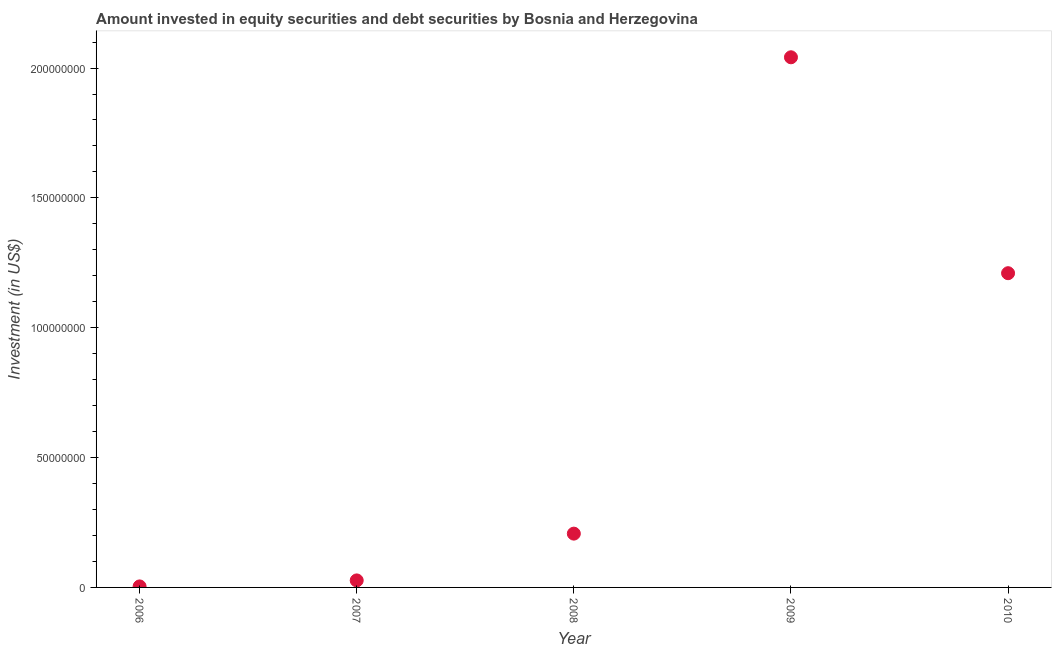What is the portfolio investment in 2006?
Give a very brief answer. 3.88e+05. Across all years, what is the maximum portfolio investment?
Give a very brief answer. 2.04e+08. Across all years, what is the minimum portfolio investment?
Your answer should be very brief. 3.88e+05. What is the sum of the portfolio investment?
Provide a succinct answer. 3.49e+08. What is the difference between the portfolio investment in 2006 and 2007?
Ensure brevity in your answer.  -2.31e+06. What is the average portfolio investment per year?
Your answer should be compact. 6.98e+07. What is the median portfolio investment?
Your answer should be compact. 2.07e+07. In how many years, is the portfolio investment greater than 90000000 US$?
Give a very brief answer. 2. What is the ratio of the portfolio investment in 2006 to that in 2008?
Ensure brevity in your answer.  0.02. What is the difference between the highest and the second highest portfolio investment?
Your answer should be compact. 8.31e+07. What is the difference between the highest and the lowest portfolio investment?
Keep it short and to the point. 2.04e+08. In how many years, is the portfolio investment greater than the average portfolio investment taken over all years?
Keep it short and to the point. 2. What is the difference between two consecutive major ticks on the Y-axis?
Provide a short and direct response. 5.00e+07. What is the title of the graph?
Keep it short and to the point. Amount invested in equity securities and debt securities by Bosnia and Herzegovina. What is the label or title of the Y-axis?
Ensure brevity in your answer.  Investment (in US$). What is the Investment (in US$) in 2006?
Ensure brevity in your answer.  3.88e+05. What is the Investment (in US$) in 2007?
Your answer should be very brief. 2.70e+06. What is the Investment (in US$) in 2008?
Make the answer very short. 2.07e+07. What is the Investment (in US$) in 2009?
Offer a very short reply. 2.04e+08. What is the Investment (in US$) in 2010?
Your answer should be compact. 1.21e+08. What is the difference between the Investment (in US$) in 2006 and 2007?
Offer a very short reply. -2.31e+06. What is the difference between the Investment (in US$) in 2006 and 2008?
Make the answer very short. -2.03e+07. What is the difference between the Investment (in US$) in 2006 and 2009?
Ensure brevity in your answer.  -2.04e+08. What is the difference between the Investment (in US$) in 2006 and 2010?
Offer a very short reply. -1.21e+08. What is the difference between the Investment (in US$) in 2007 and 2008?
Offer a very short reply. -1.80e+07. What is the difference between the Investment (in US$) in 2007 and 2009?
Offer a terse response. -2.01e+08. What is the difference between the Investment (in US$) in 2007 and 2010?
Ensure brevity in your answer.  -1.18e+08. What is the difference between the Investment (in US$) in 2008 and 2009?
Make the answer very short. -1.83e+08. What is the difference between the Investment (in US$) in 2008 and 2010?
Provide a short and direct response. -1.00e+08. What is the difference between the Investment (in US$) in 2009 and 2010?
Provide a succinct answer. 8.31e+07. What is the ratio of the Investment (in US$) in 2006 to that in 2007?
Offer a very short reply. 0.14. What is the ratio of the Investment (in US$) in 2006 to that in 2008?
Give a very brief answer. 0.02. What is the ratio of the Investment (in US$) in 2006 to that in 2009?
Make the answer very short. 0. What is the ratio of the Investment (in US$) in 2006 to that in 2010?
Give a very brief answer. 0. What is the ratio of the Investment (in US$) in 2007 to that in 2008?
Keep it short and to the point. 0.13. What is the ratio of the Investment (in US$) in 2007 to that in 2009?
Your answer should be very brief. 0.01. What is the ratio of the Investment (in US$) in 2007 to that in 2010?
Make the answer very short. 0.02. What is the ratio of the Investment (in US$) in 2008 to that in 2009?
Keep it short and to the point. 0.1. What is the ratio of the Investment (in US$) in 2008 to that in 2010?
Give a very brief answer. 0.17. What is the ratio of the Investment (in US$) in 2009 to that in 2010?
Give a very brief answer. 1.69. 